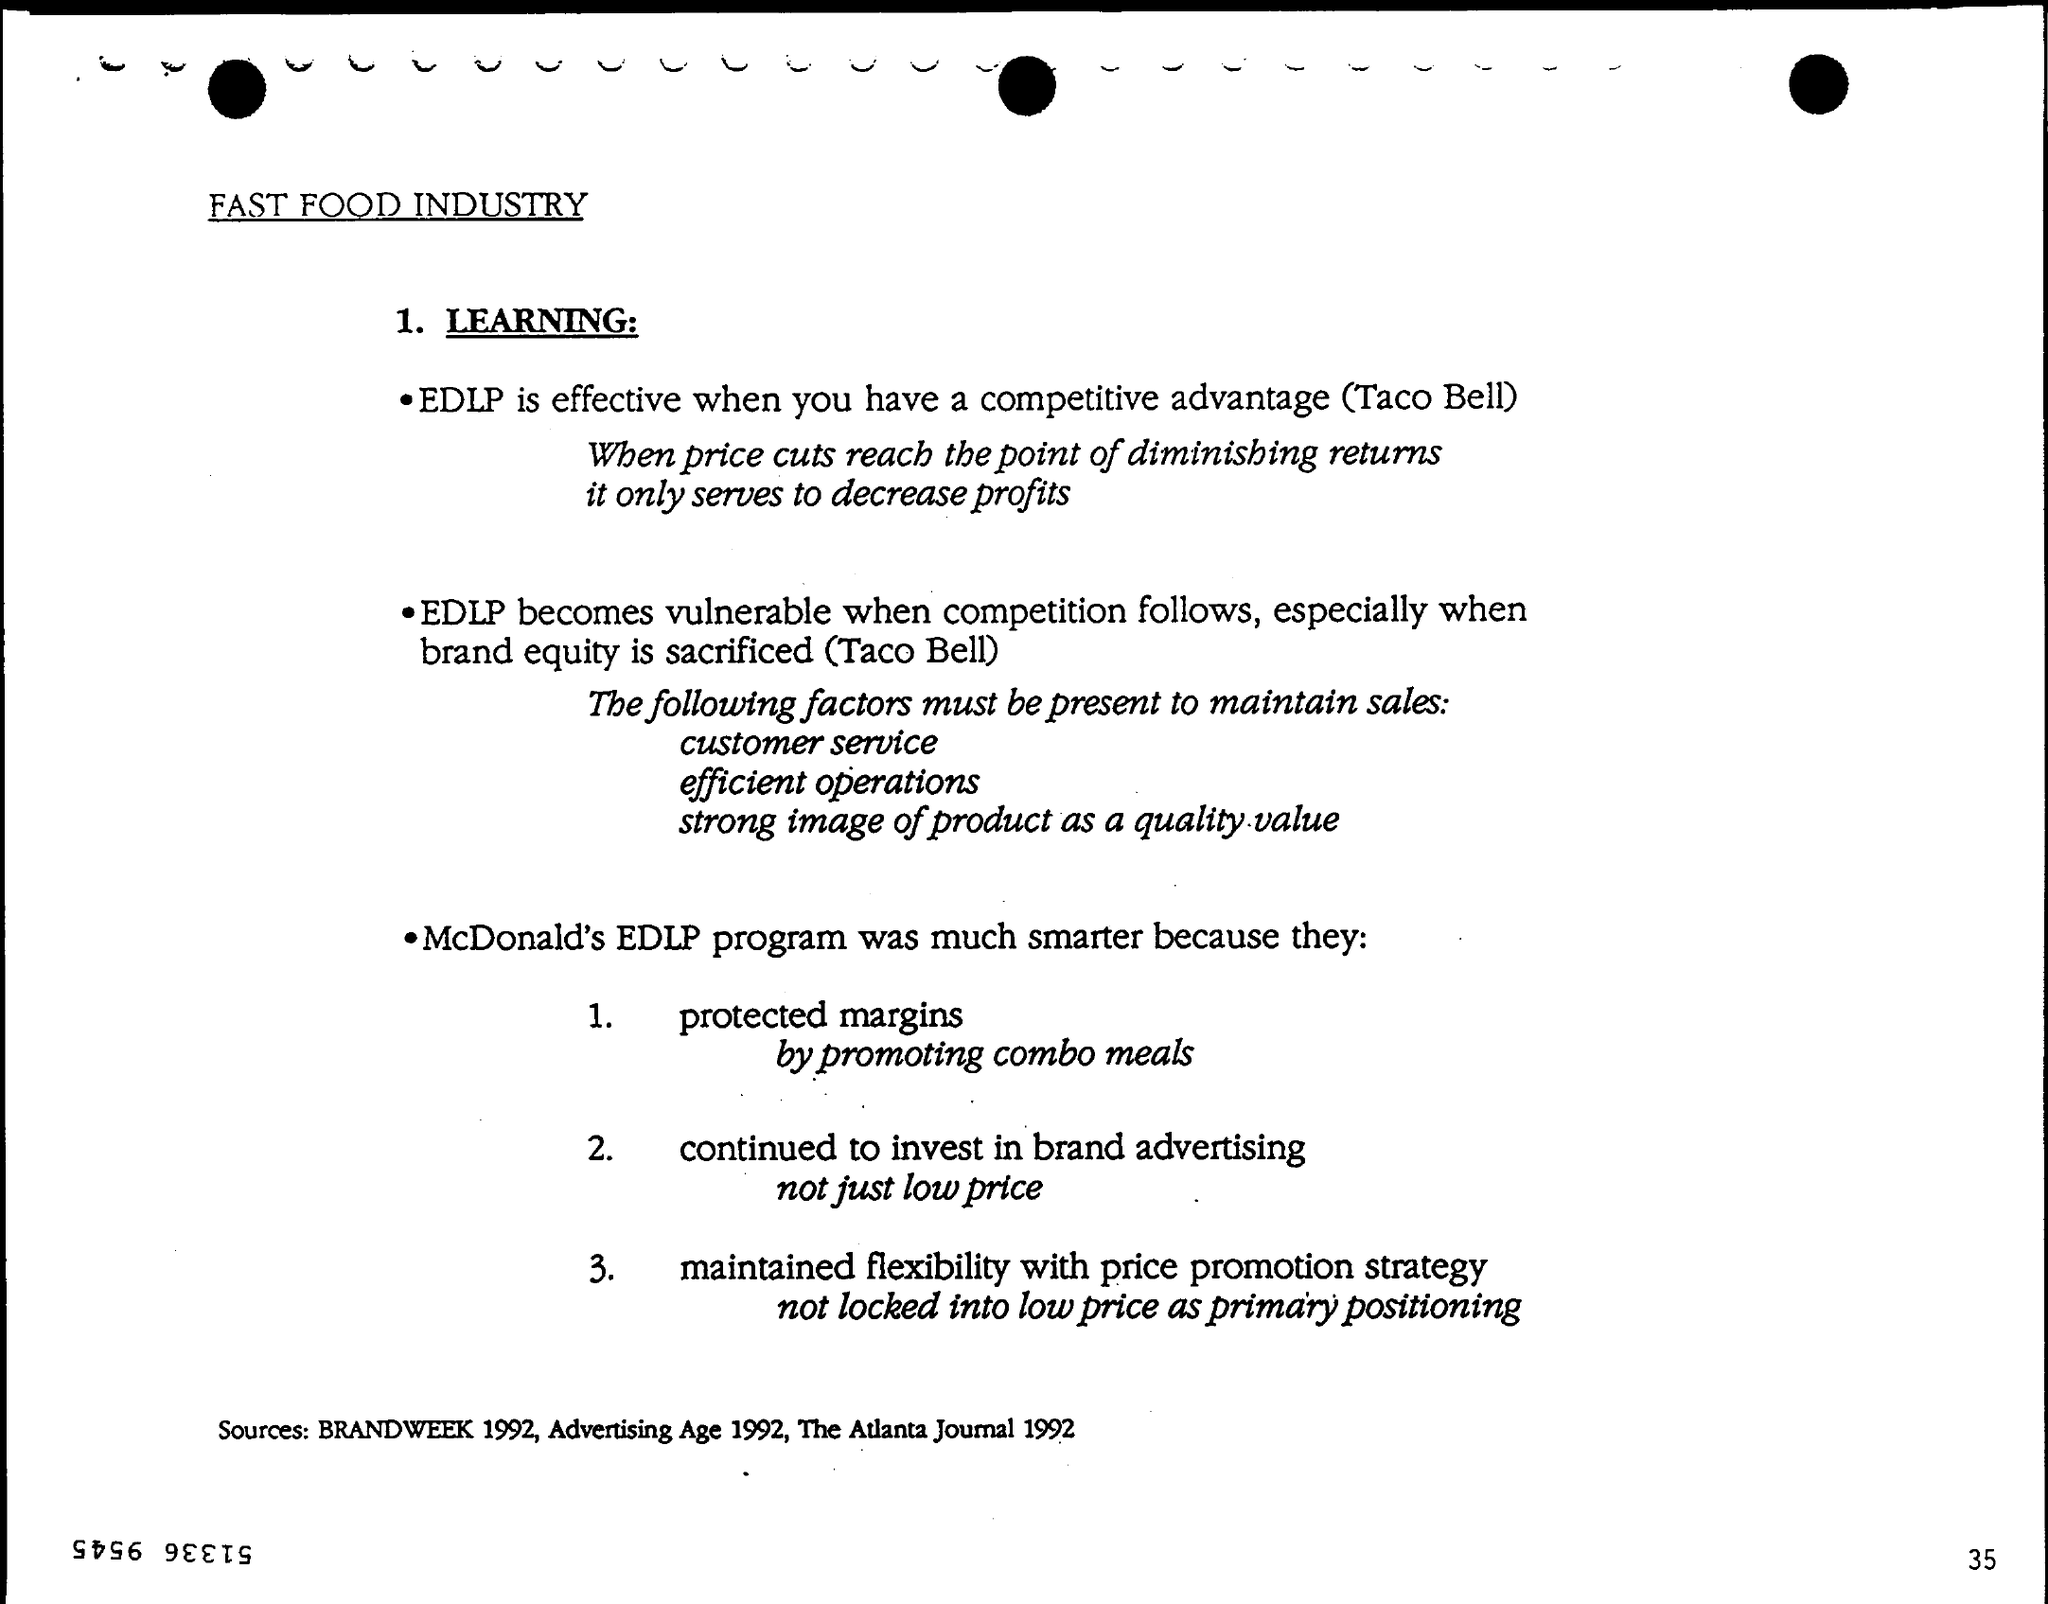Draw attention to some important aspects in this diagram. The sources mentioned in the text are "Brandweek 1992, Advertising Age 1992, and The Atlanta Journal 1992. McDonald's protected its margins by promoting combo meals, which encouraged customers to purchase more items from the menu, thereby increasing revenue for the company. 